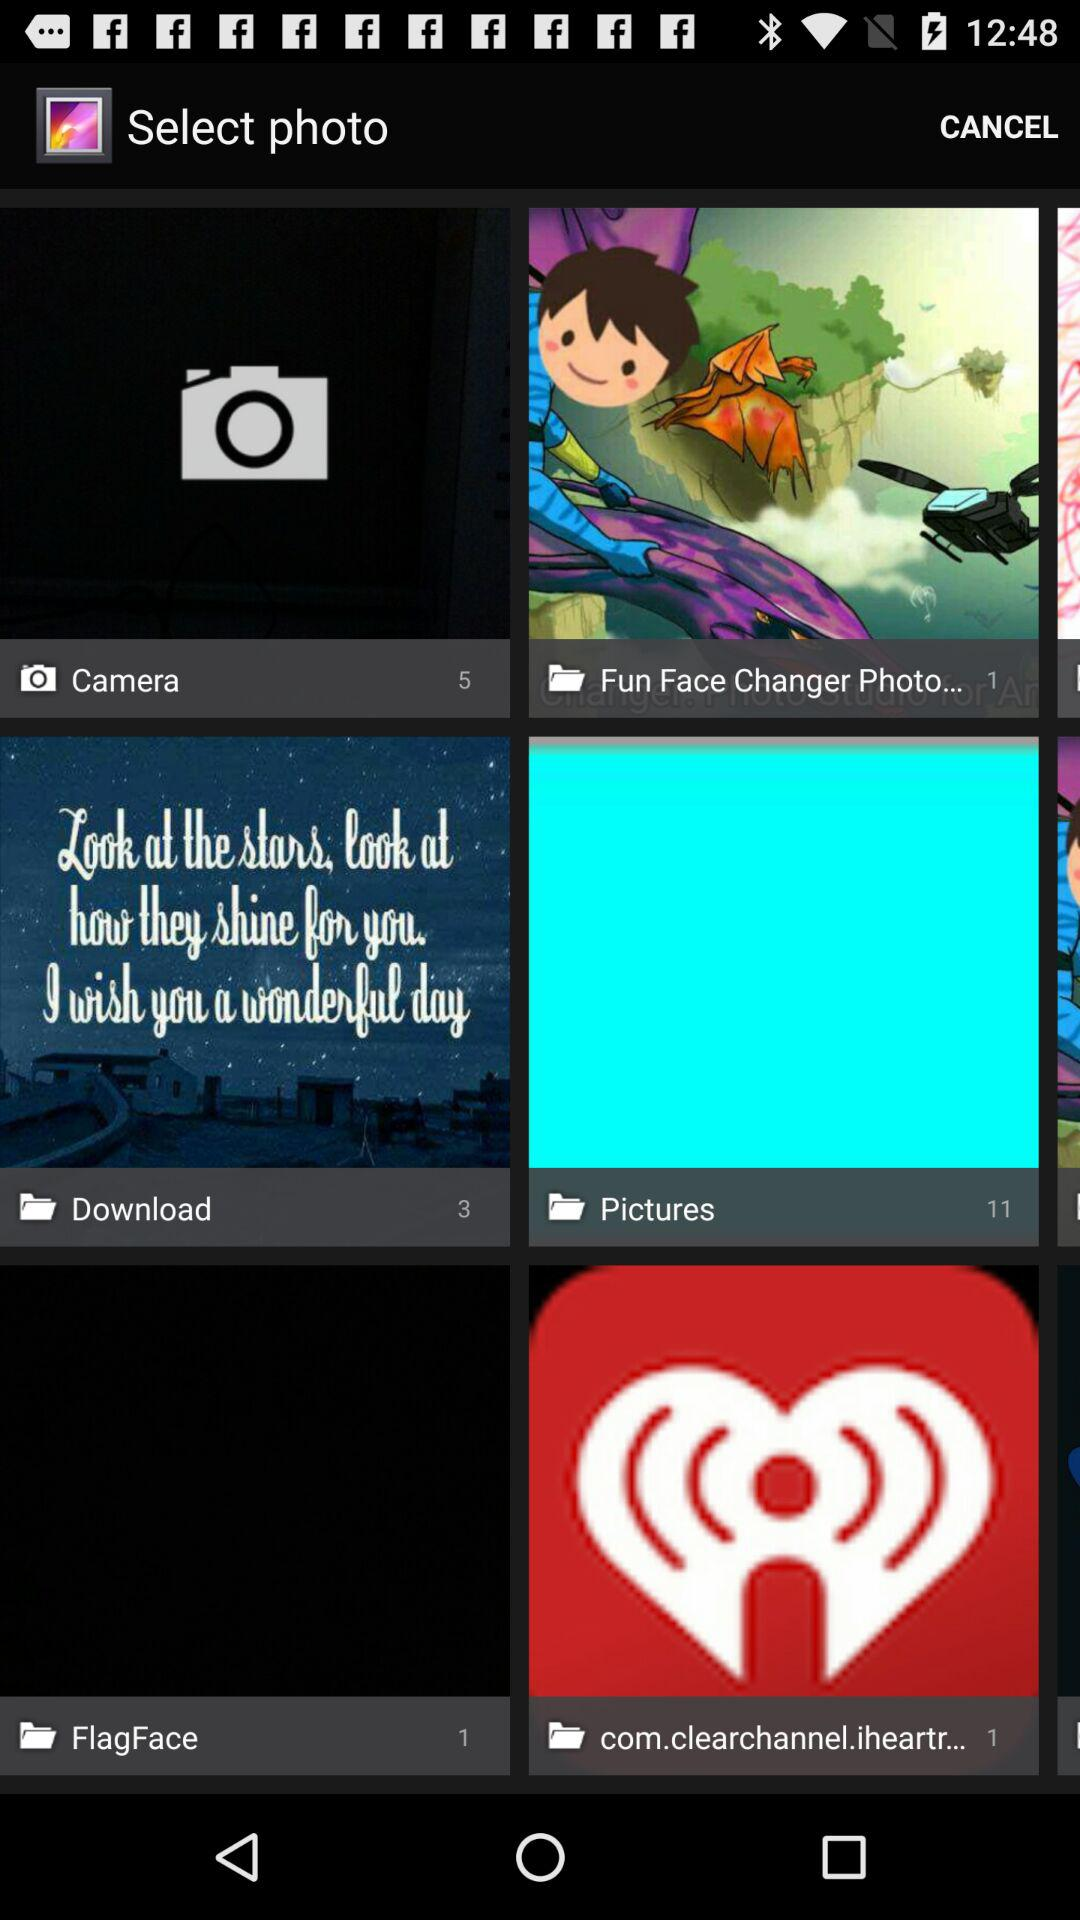How many items have a photo in the first row?
Answer the question using a single word or phrase. 2 